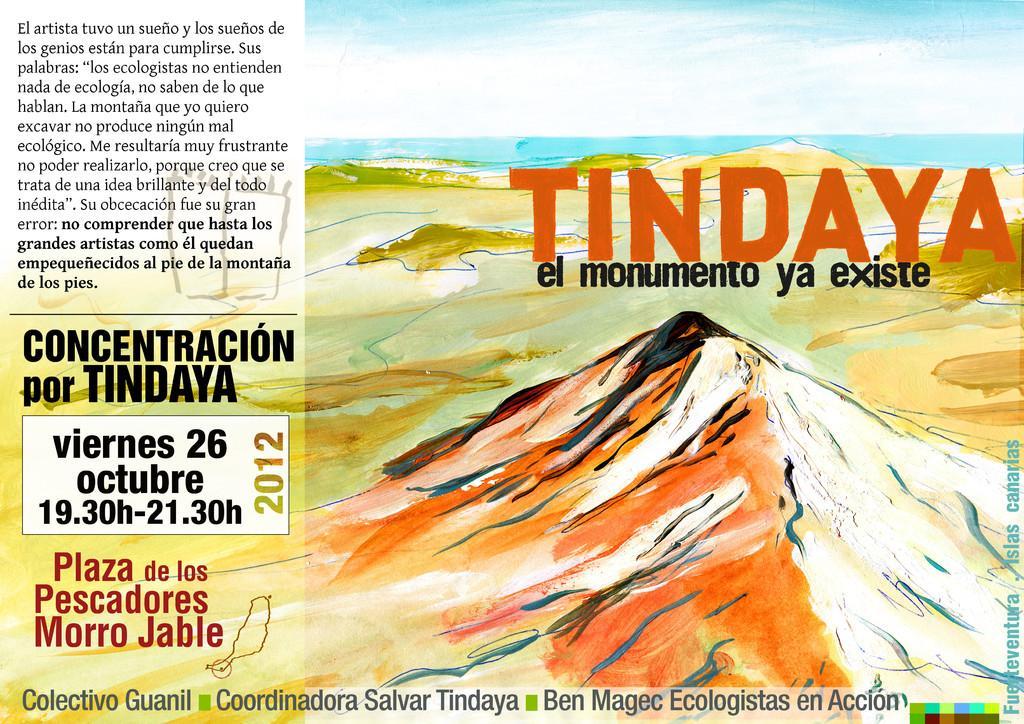Please provide a concise description of this image. In this image there is a poster, on that poster there is some text and land, the sea and the sky. 